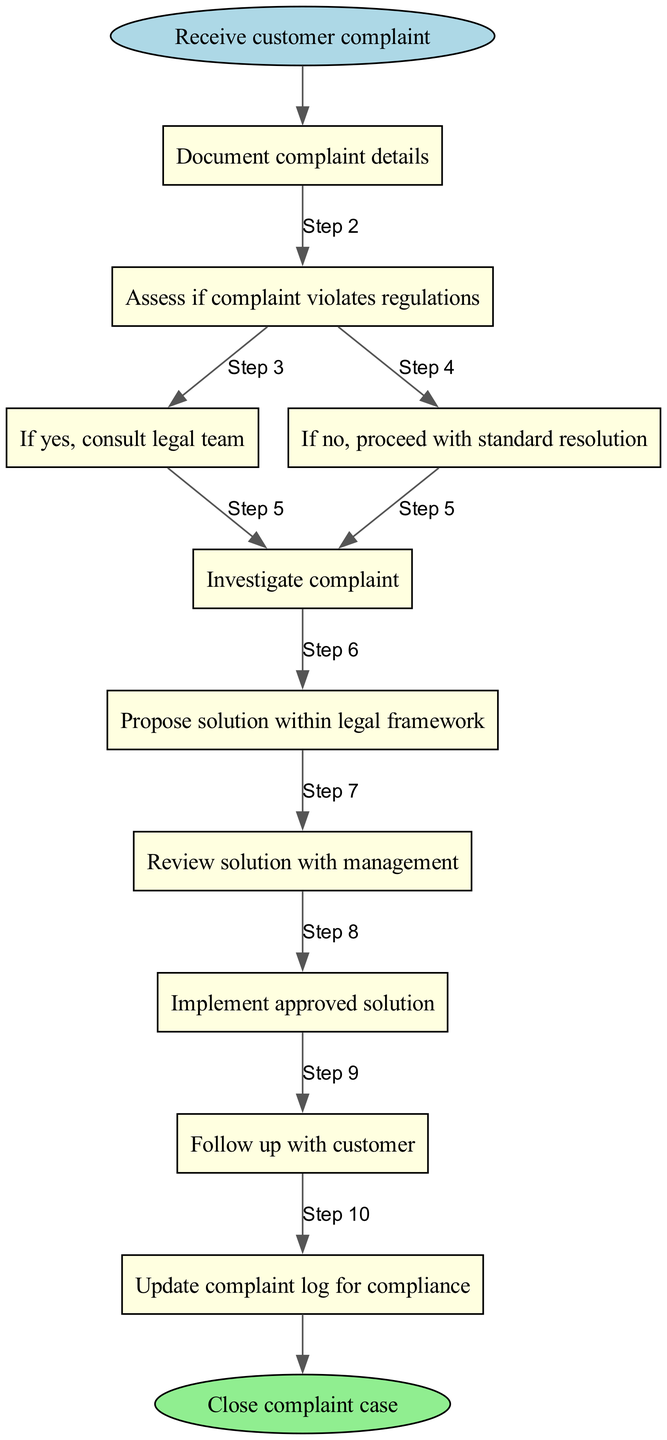What is the first step in the complaint handling protocol? The first step in the protocol is "Receive customer complaint," which is clearly stated as the starting point.
Answer: Receive customer complaint How many steps are there in total? There are 10 steps in the protocol, counting from the initial complaint to closing the complaint case.
Answer: 10 Which step comes after "Document complaint details"? After "Document complaint details," the next step is "Assess if complaint violates regulations," indicating a decision point based on the assessment.
Answer: Assess if complaint violates regulations What happens if the assessment shows a violation of regulations? If the assessment shows a violation, the next action is to "If yes, consult legal team," indicating the necessity to engage legal counsel.
Answer: Consult legal team What is the final action taken in the complaint resolution process? The final action taken in the process is "Close complaint case," which signifies the end of the complaint handling protocol.
Answer: Close complaint case What is required to be done after proposing a solution? After proposing a solution, the next requirement is to "Review solution with management," ensuring that any proposed solution is validated before implementation.
Answer: Review solution with management In which step do you follow up with the customer? The step where you follow up with the customer is "Follow up with customer," confirming user engagement after implementing a solution.
Answer: Follow up with customer What action directly follows assessing if the complaint violates regulations? The action that directly follows is either to "If yes, consult legal team" or "If no, proceed with standard resolution," depending on the outcome of the assessment.
Answer: Consult legal team / Proceed with standard resolution (either is correct based on context) What type of node is used to represent the steps in the diagram? The nodes representing the steps in the diagram are of the type "box," indicating process actions within the protocol.
Answer: Box 